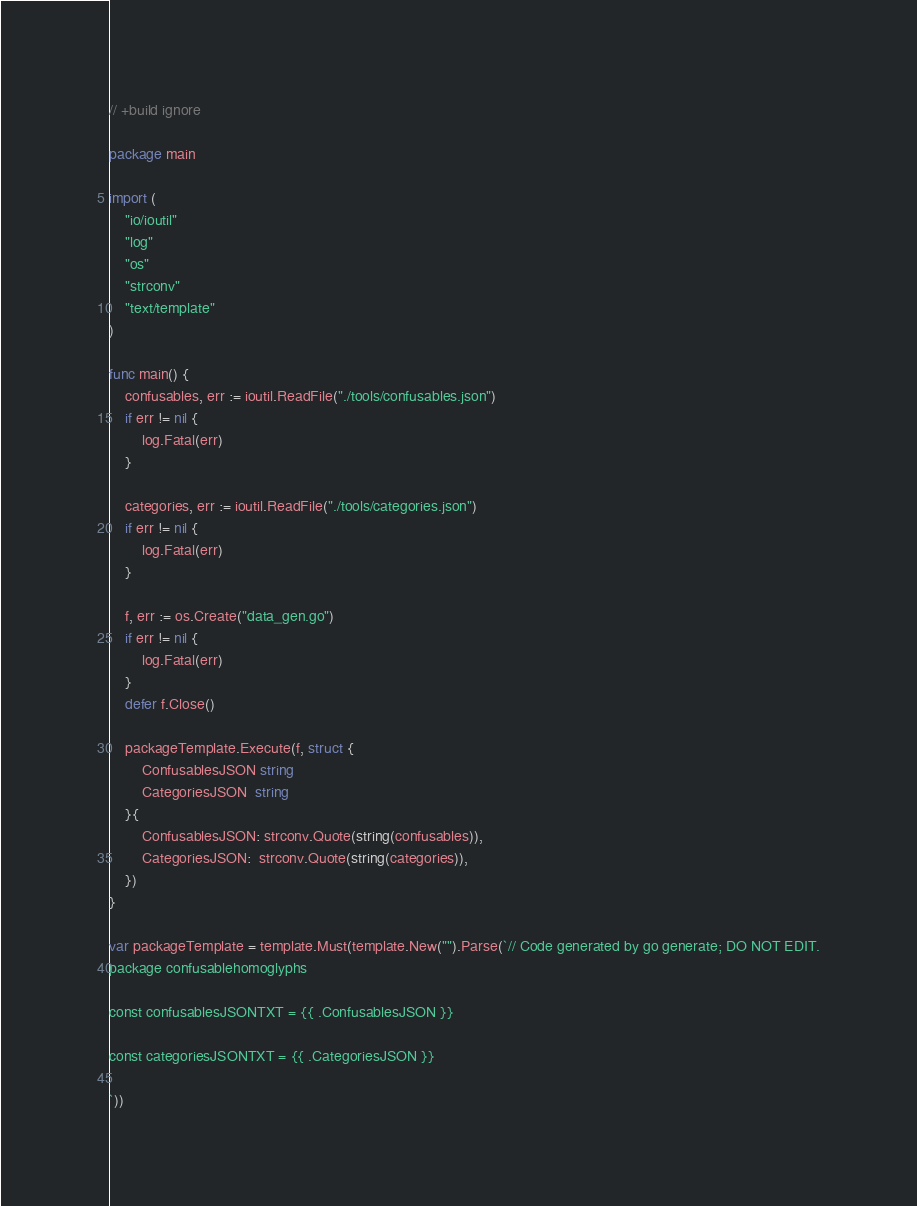Convert code to text. <code><loc_0><loc_0><loc_500><loc_500><_Go_>// +build ignore

package main

import (
	"io/ioutil"
	"log"
	"os"
	"strconv"
	"text/template"
)

func main() {
	confusables, err := ioutil.ReadFile("./tools/confusables.json")
	if err != nil {
		log.Fatal(err)
	}

	categories, err := ioutil.ReadFile("./tools/categories.json")
	if err != nil {
		log.Fatal(err)
	}

	f, err := os.Create("data_gen.go")
	if err != nil {
		log.Fatal(err)
	}
	defer f.Close()

	packageTemplate.Execute(f, struct {
		ConfusablesJSON string
		CategoriesJSON  string
	}{
		ConfusablesJSON: strconv.Quote(string(confusables)),
		CategoriesJSON:  strconv.Quote(string(categories)),
	})
}

var packageTemplate = template.Must(template.New("").Parse(`// Code generated by go generate; DO NOT EDIT.
package confusablehomoglyphs

const confusablesJSONTXT = {{ .ConfusablesJSON }}

const categoriesJSONTXT = {{ .CategoriesJSON }}

`))
</code> 